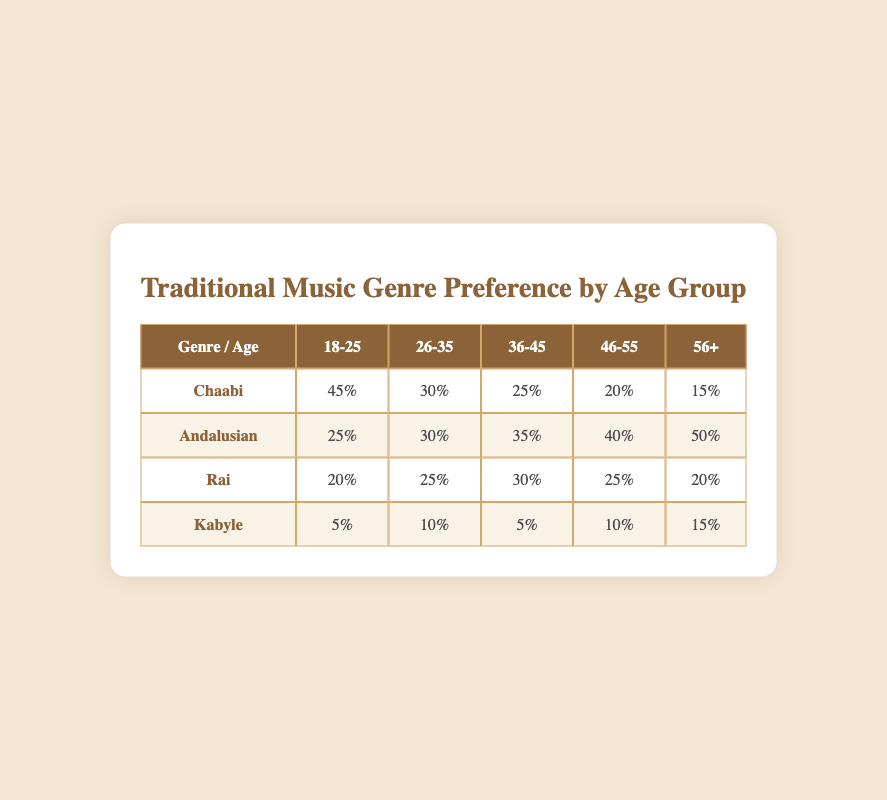What genre has the highest preference among the 18-25 age group? In the 18-25 age group, the preference percentages are as follows: Chaabi 45%, Andalusian 25%, Rai 20%, and Kabyle 5%. The highest percentage is for Chaabi at 45%.
Answer: Chaabi What is the preference of the 56+ age group for Andalusian music? The preference percentage for Andalusian music in the 56+ age group is provided in the table and is equal to 50%.
Answer: 50% How many percentage points more do 46-55 year-olds prefer Andalusian music compared to Rai music? The preference for Andalusian in the 46-55 age group is 40% and for Rai is 25%. To find the difference, we subtract 25% from 40%, which equals 15 percentage points.
Answer: 15 Is it true that Kabyle music is preferred more by the 56+ age group than by the 18-25 age group? The percentages show that Kabyle music preference in the 56+ age group is 15% and in the 18-25 group is 5%. Since 15% is greater than 5%, the statement is true.
Answer: Yes What is the total percentage preference for Chaabi music across all age groups? Summing the preferences for Chaabi across all age groups gives: 45% + 30% + 25% + 20% + 15% = 135%. Therefore, the total percentage is 135%.
Answer: 135% What genre has the least preference among the 36-45 age group? The percentages for the 36-45 age group are: Chaabi 25%, Andalusian 35%, Rai 30%, and Kabyle 5%. The lowest percentage is for Kabyle at 5%.
Answer: Kabyle Which age group prefers Rai music the most? The percentages for Rai music by age group are: 20% (18-25), 25% (26-35), 30% (36-45), 25% (46-55), and 20% (56+). The highest preference is 30% in the 36-45 age group.
Answer: 36-45 What is the average preference for Kabyle music across all age groups? The preference percentages for Kabyle are: 5%, 10%, 5%, 10%, and 15%. To find the average, we sum them: 5% + 10% + 5% + 10% + 15% = 45%, then divide by 5 (the number of age groups), resulting in an average of 9%.
Answer: 9% 